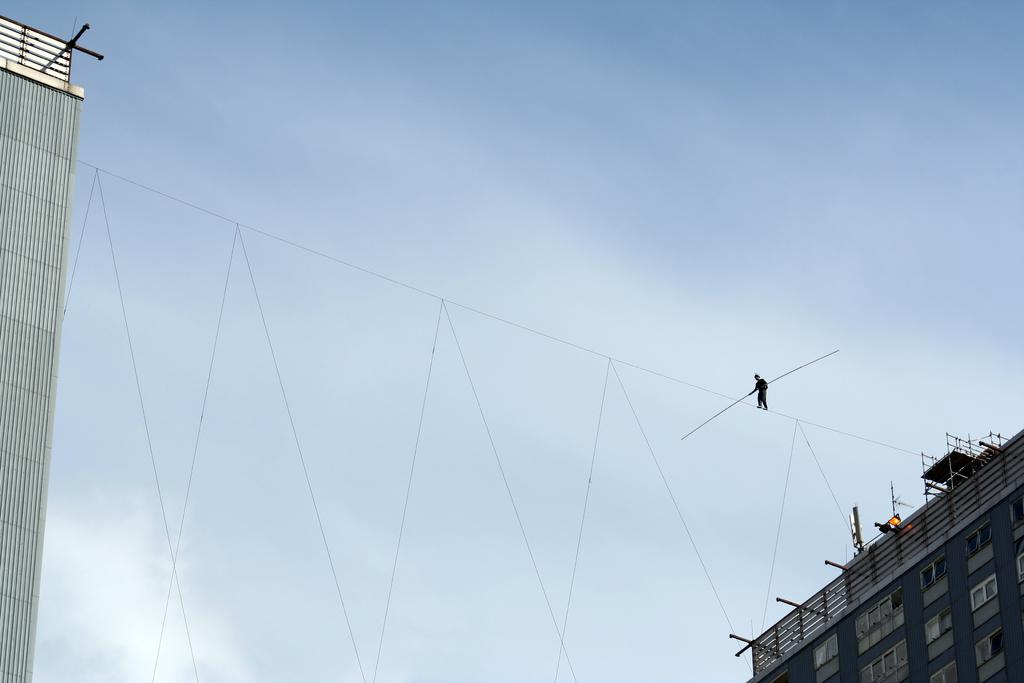What is the person in the image holding? There is a person holding an object in the image. What else can be seen in the image besides the person? There are ropes visible in the image. What type of structures are present in the image? There are buildings in the image. What part of the natural environment is visible in the image? The sky is visible in the middle of the image. Can you see any frogs jumping around in the image? There are no frogs present in the image. What type of jar is being used to hold the sticks in the image? There is no jar or sticks present in the image. 